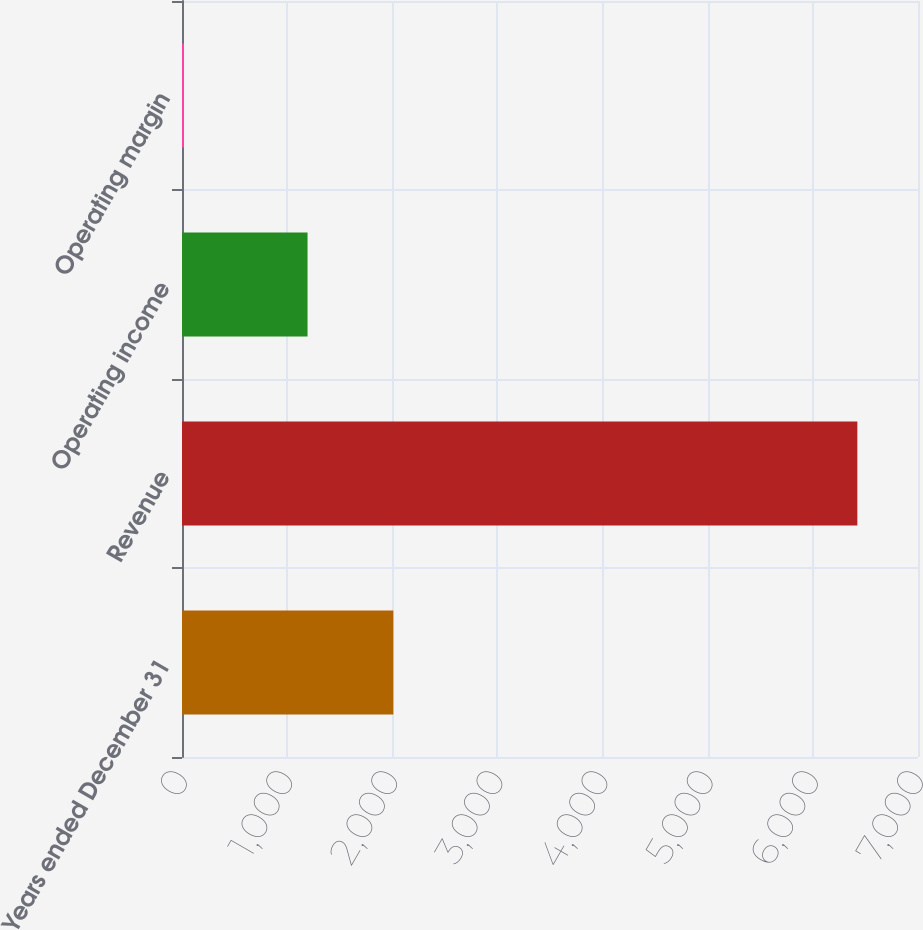Convert chart to OTSL. <chart><loc_0><loc_0><loc_500><loc_500><bar_chart><fcel>Years ended December 31<fcel>Revenue<fcel>Operating income<fcel>Operating margin<nl><fcel>2010<fcel>6423<fcel>1194<fcel>18.6<nl></chart> 